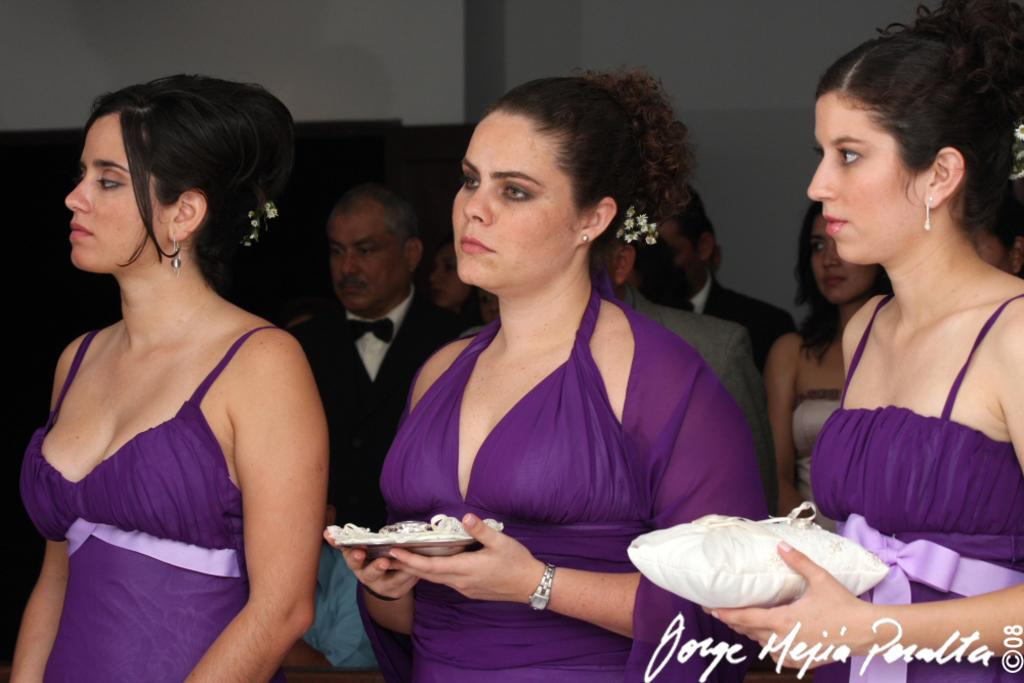How many people are in the group that is visible in the image? There is a group of people standing in the image, but the exact number is not specified. What are the two women holding in the image? Two women are holding objects in the image, but the nature of these objects is not described. What is the background feature in the image? There is a wall in the image. Is there any additional information about the image itself? Yes, there is a watermark on the image. What type of slip can be seen on the floor in the image? There is no slip visible on the floor in the image. 